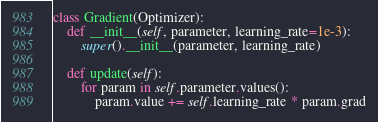<code> <loc_0><loc_0><loc_500><loc_500><_Python_>

class Gradient(Optimizer):
    def __init__(self, parameter, learning_rate=1e-3):
        super().__init__(parameter, learning_rate)

    def update(self):
        for param in self.parameter.values():
            param.value += self.learning_rate * param.grad
</code> 